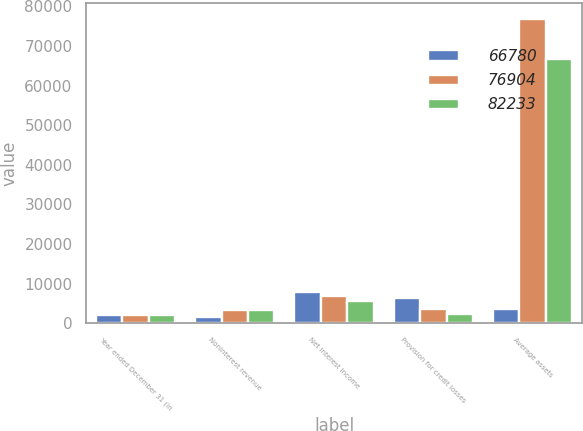<chart> <loc_0><loc_0><loc_500><loc_500><stacked_bar_chart><ecel><fcel>Year ended December 31 (in<fcel>Noninterest revenue<fcel>Net interest income<fcel>Provision for credit losses<fcel>Average assets<nl><fcel>66780<fcel>2009<fcel>1494<fcel>7937<fcel>6443<fcel>3472.5<nl><fcel>76904<fcel>2008<fcel>3333<fcel>6945<fcel>3612<fcel>76904<nl><fcel>82233<fcel>2007<fcel>3255<fcel>5635<fcel>2380<fcel>66780<nl></chart> 